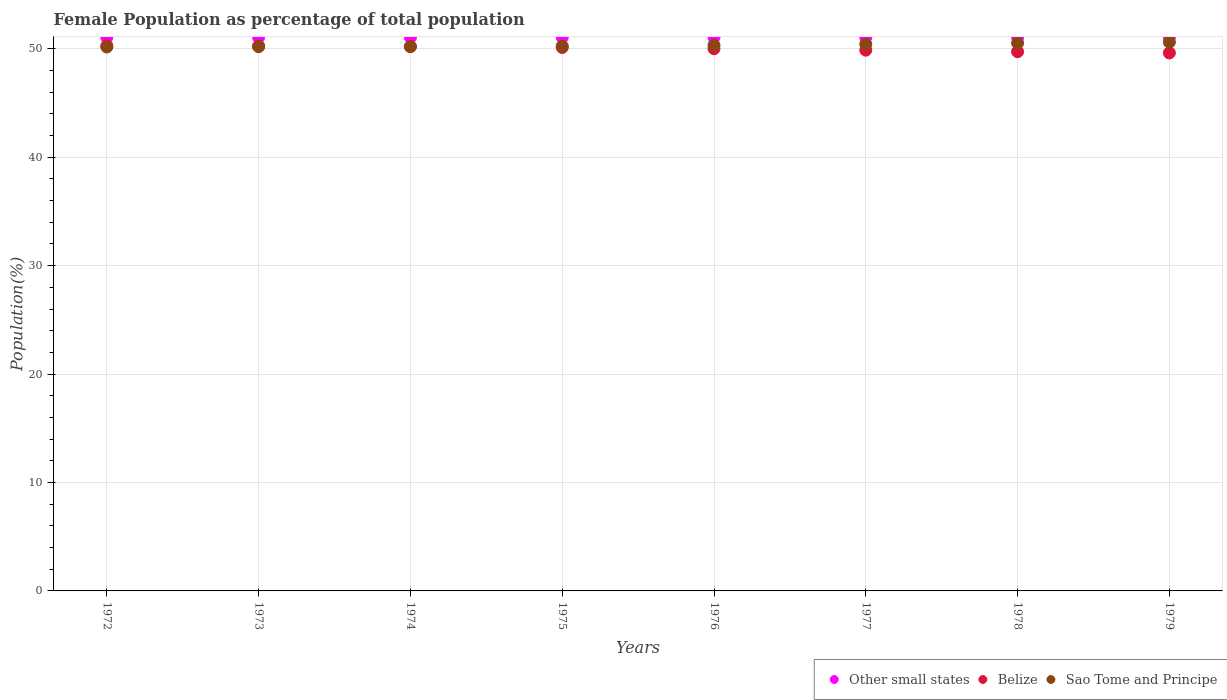How many different coloured dotlines are there?
Ensure brevity in your answer.  3. What is the female population in in Other small states in 1973?
Provide a succinct answer. 51.06. Across all years, what is the maximum female population in in Sao Tome and Principe?
Offer a very short reply. 50.61. Across all years, what is the minimum female population in in Sao Tome and Principe?
Provide a short and direct response. 50.17. In which year was the female population in in Other small states maximum?
Your answer should be very brief. 1976. In which year was the female population in in Belize minimum?
Your response must be concise. 1979. What is the total female population in in Belize in the graph?
Make the answer very short. 400.12. What is the difference between the female population in in Other small states in 1974 and that in 1975?
Keep it short and to the point. -0. What is the difference between the female population in in Belize in 1979 and the female population in in Sao Tome and Principe in 1972?
Make the answer very short. -0.55. What is the average female population in in Belize per year?
Ensure brevity in your answer.  50.02. In the year 1974, what is the difference between the female population in in Sao Tome and Principe and female population in in Belize?
Offer a terse response. 0.01. What is the ratio of the female population in in Sao Tome and Principe in 1975 to that in 1977?
Ensure brevity in your answer.  1. What is the difference between the highest and the second highest female population in in Sao Tome and Principe?
Keep it short and to the point. 0.08. What is the difference between the highest and the lowest female population in in Belize?
Offer a terse response. 0.67. In how many years, is the female population in in Sao Tome and Principe greater than the average female population in in Sao Tome and Principe taken over all years?
Keep it short and to the point. 3. Is the sum of the female population in in Other small states in 1974 and 1979 greater than the maximum female population in in Sao Tome and Principe across all years?
Your response must be concise. Yes. Does the female population in in Sao Tome and Principe monotonically increase over the years?
Provide a succinct answer. Yes. Is the female population in in Sao Tome and Principe strictly greater than the female population in in Belize over the years?
Give a very brief answer. No. How many years are there in the graph?
Your response must be concise. 8. What is the difference between two consecutive major ticks on the Y-axis?
Your response must be concise. 10. Does the graph contain any zero values?
Your answer should be very brief. No. Does the graph contain grids?
Keep it short and to the point. Yes. Where does the legend appear in the graph?
Your answer should be compact. Bottom right. How are the legend labels stacked?
Your answer should be very brief. Horizontal. What is the title of the graph?
Keep it short and to the point. Female Population as percentage of total population. What is the label or title of the X-axis?
Provide a short and direct response. Years. What is the label or title of the Y-axis?
Provide a short and direct response. Population(%). What is the Population(%) of Other small states in 1972?
Offer a terse response. 51.05. What is the Population(%) in Belize in 1972?
Your answer should be very brief. 50.29. What is the Population(%) in Sao Tome and Principe in 1972?
Your answer should be very brief. 50.17. What is the Population(%) in Other small states in 1973?
Keep it short and to the point. 51.06. What is the Population(%) in Belize in 1973?
Ensure brevity in your answer.  50.26. What is the Population(%) of Sao Tome and Principe in 1973?
Make the answer very short. 50.2. What is the Population(%) of Other small states in 1974?
Give a very brief answer. 51.06. What is the Population(%) of Belize in 1974?
Offer a terse response. 50.2. What is the Population(%) of Sao Tome and Principe in 1974?
Make the answer very short. 50.21. What is the Population(%) of Other small states in 1975?
Provide a short and direct response. 51.06. What is the Population(%) of Belize in 1975?
Offer a terse response. 50.12. What is the Population(%) of Sao Tome and Principe in 1975?
Ensure brevity in your answer.  50.26. What is the Population(%) in Other small states in 1976?
Keep it short and to the point. 51.06. What is the Population(%) in Belize in 1976?
Your response must be concise. 50.01. What is the Population(%) of Sao Tome and Principe in 1976?
Give a very brief answer. 50.33. What is the Population(%) of Other small states in 1977?
Provide a short and direct response. 51.06. What is the Population(%) of Belize in 1977?
Offer a very short reply. 49.88. What is the Population(%) of Sao Tome and Principe in 1977?
Make the answer very short. 50.43. What is the Population(%) of Other small states in 1978?
Provide a short and direct response. 51.05. What is the Population(%) of Belize in 1978?
Your answer should be compact. 49.74. What is the Population(%) in Sao Tome and Principe in 1978?
Your response must be concise. 50.53. What is the Population(%) of Other small states in 1979?
Give a very brief answer. 51.04. What is the Population(%) in Belize in 1979?
Your answer should be compact. 49.62. What is the Population(%) in Sao Tome and Principe in 1979?
Your answer should be compact. 50.61. Across all years, what is the maximum Population(%) in Other small states?
Offer a terse response. 51.06. Across all years, what is the maximum Population(%) in Belize?
Your answer should be very brief. 50.29. Across all years, what is the maximum Population(%) of Sao Tome and Principe?
Your answer should be compact. 50.61. Across all years, what is the minimum Population(%) of Other small states?
Offer a very short reply. 51.04. Across all years, what is the minimum Population(%) in Belize?
Keep it short and to the point. 49.62. Across all years, what is the minimum Population(%) of Sao Tome and Principe?
Offer a terse response. 50.17. What is the total Population(%) of Other small states in the graph?
Ensure brevity in your answer.  408.44. What is the total Population(%) in Belize in the graph?
Your response must be concise. 400.12. What is the total Population(%) in Sao Tome and Principe in the graph?
Give a very brief answer. 402.75. What is the difference between the Population(%) in Other small states in 1972 and that in 1973?
Offer a terse response. -0. What is the difference between the Population(%) in Belize in 1972 and that in 1973?
Provide a short and direct response. 0.03. What is the difference between the Population(%) in Sao Tome and Principe in 1972 and that in 1973?
Offer a very short reply. -0.03. What is the difference between the Population(%) in Other small states in 1972 and that in 1974?
Your answer should be compact. -0. What is the difference between the Population(%) in Belize in 1972 and that in 1974?
Offer a terse response. 0.08. What is the difference between the Population(%) in Sao Tome and Principe in 1972 and that in 1974?
Keep it short and to the point. -0.05. What is the difference between the Population(%) in Other small states in 1972 and that in 1975?
Make the answer very short. -0. What is the difference between the Population(%) in Belize in 1972 and that in 1975?
Provide a short and direct response. 0.16. What is the difference between the Population(%) in Sao Tome and Principe in 1972 and that in 1975?
Your answer should be very brief. -0.09. What is the difference between the Population(%) in Other small states in 1972 and that in 1976?
Your answer should be very brief. -0. What is the difference between the Population(%) in Belize in 1972 and that in 1976?
Provide a short and direct response. 0.28. What is the difference between the Population(%) of Sao Tome and Principe in 1972 and that in 1976?
Your response must be concise. -0.16. What is the difference between the Population(%) of Other small states in 1972 and that in 1977?
Your response must be concise. -0. What is the difference between the Population(%) in Belize in 1972 and that in 1977?
Make the answer very short. 0.41. What is the difference between the Population(%) of Sao Tome and Principe in 1972 and that in 1977?
Give a very brief answer. -0.26. What is the difference between the Population(%) of Other small states in 1972 and that in 1978?
Your answer should be compact. 0. What is the difference between the Population(%) of Belize in 1972 and that in 1978?
Offer a very short reply. 0.55. What is the difference between the Population(%) of Sao Tome and Principe in 1972 and that in 1978?
Ensure brevity in your answer.  -0.36. What is the difference between the Population(%) of Other small states in 1972 and that in 1979?
Ensure brevity in your answer.  0.01. What is the difference between the Population(%) in Belize in 1972 and that in 1979?
Your response must be concise. 0.67. What is the difference between the Population(%) in Sao Tome and Principe in 1972 and that in 1979?
Offer a very short reply. -0.44. What is the difference between the Population(%) in Other small states in 1973 and that in 1974?
Offer a terse response. -0. What is the difference between the Population(%) of Belize in 1973 and that in 1974?
Give a very brief answer. 0.05. What is the difference between the Population(%) in Sao Tome and Principe in 1973 and that in 1974?
Give a very brief answer. -0.02. What is the difference between the Population(%) of Other small states in 1973 and that in 1975?
Offer a very short reply. -0. What is the difference between the Population(%) of Belize in 1973 and that in 1975?
Offer a terse response. 0.13. What is the difference between the Population(%) of Sao Tome and Principe in 1973 and that in 1975?
Provide a short and direct response. -0.06. What is the difference between the Population(%) of Other small states in 1973 and that in 1976?
Keep it short and to the point. -0. What is the difference between the Population(%) of Belize in 1973 and that in 1976?
Keep it short and to the point. 0.24. What is the difference between the Population(%) of Sao Tome and Principe in 1973 and that in 1976?
Your response must be concise. -0.14. What is the difference between the Population(%) in Other small states in 1973 and that in 1977?
Offer a very short reply. -0. What is the difference between the Population(%) in Belize in 1973 and that in 1977?
Offer a terse response. 0.38. What is the difference between the Population(%) in Sao Tome and Principe in 1973 and that in 1977?
Your answer should be compact. -0.23. What is the difference between the Population(%) in Other small states in 1973 and that in 1978?
Provide a short and direct response. 0. What is the difference between the Population(%) in Belize in 1973 and that in 1978?
Provide a succinct answer. 0.52. What is the difference between the Population(%) in Sao Tome and Principe in 1973 and that in 1978?
Keep it short and to the point. -0.33. What is the difference between the Population(%) of Other small states in 1973 and that in 1979?
Give a very brief answer. 0.01. What is the difference between the Population(%) of Belize in 1973 and that in 1979?
Provide a short and direct response. 0.64. What is the difference between the Population(%) in Sao Tome and Principe in 1973 and that in 1979?
Your answer should be very brief. -0.42. What is the difference between the Population(%) in Other small states in 1974 and that in 1975?
Keep it short and to the point. -0. What is the difference between the Population(%) in Belize in 1974 and that in 1975?
Offer a very short reply. 0.08. What is the difference between the Population(%) of Sao Tome and Principe in 1974 and that in 1975?
Provide a short and direct response. -0.04. What is the difference between the Population(%) in Other small states in 1974 and that in 1976?
Ensure brevity in your answer.  -0. What is the difference between the Population(%) in Belize in 1974 and that in 1976?
Your answer should be compact. 0.19. What is the difference between the Population(%) in Sao Tome and Principe in 1974 and that in 1976?
Provide a short and direct response. -0.12. What is the difference between the Population(%) of Other small states in 1974 and that in 1977?
Your response must be concise. -0. What is the difference between the Population(%) in Belize in 1974 and that in 1977?
Provide a short and direct response. 0.33. What is the difference between the Population(%) in Sao Tome and Principe in 1974 and that in 1977?
Ensure brevity in your answer.  -0.22. What is the difference between the Population(%) in Other small states in 1974 and that in 1978?
Offer a very short reply. 0. What is the difference between the Population(%) of Belize in 1974 and that in 1978?
Offer a terse response. 0.47. What is the difference between the Population(%) of Sao Tome and Principe in 1974 and that in 1978?
Your answer should be compact. -0.32. What is the difference between the Population(%) of Other small states in 1974 and that in 1979?
Your answer should be very brief. 0.01. What is the difference between the Population(%) of Belize in 1974 and that in 1979?
Offer a terse response. 0.58. What is the difference between the Population(%) of Sao Tome and Principe in 1974 and that in 1979?
Provide a succinct answer. -0.4. What is the difference between the Population(%) in Other small states in 1975 and that in 1976?
Provide a succinct answer. -0. What is the difference between the Population(%) of Belize in 1975 and that in 1976?
Provide a short and direct response. 0.11. What is the difference between the Population(%) of Sao Tome and Principe in 1975 and that in 1976?
Offer a terse response. -0.08. What is the difference between the Population(%) in Other small states in 1975 and that in 1977?
Provide a succinct answer. -0. What is the difference between the Population(%) in Belize in 1975 and that in 1977?
Offer a terse response. 0.25. What is the difference between the Population(%) in Sao Tome and Principe in 1975 and that in 1977?
Ensure brevity in your answer.  -0.18. What is the difference between the Population(%) of Other small states in 1975 and that in 1978?
Offer a very short reply. 0. What is the difference between the Population(%) in Belize in 1975 and that in 1978?
Your answer should be compact. 0.39. What is the difference between the Population(%) in Sao Tome and Principe in 1975 and that in 1978?
Keep it short and to the point. -0.28. What is the difference between the Population(%) in Other small states in 1975 and that in 1979?
Make the answer very short. 0.01. What is the difference between the Population(%) of Belize in 1975 and that in 1979?
Give a very brief answer. 0.5. What is the difference between the Population(%) in Sao Tome and Principe in 1975 and that in 1979?
Provide a short and direct response. -0.36. What is the difference between the Population(%) in Belize in 1976 and that in 1977?
Keep it short and to the point. 0.14. What is the difference between the Population(%) in Sao Tome and Principe in 1976 and that in 1977?
Your answer should be very brief. -0.1. What is the difference between the Population(%) in Other small states in 1976 and that in 1978?
Keep it short and to the point. 0. What is the difference between the Population(%) in Belize in 1976 and that in 1978?
Your response must be concise. 0.28. What is the difference between the Population(%) in Sao Tome and Principe in 1976 and that in 1978?
Provide a succinct answer. -0.2. What is the difference between the Population(%) of Other small states in 1976 and that in 1979?
Provide a short and direct response. 0.01. What is the difference between the Population(%) of Belize in 1976 and that in 1979?
Keep it short and to the point. 0.39. What is the difference between the Population(%) in Sao Tome and Principe in 1976 and that in 1979?
Ensure brevity in your answer.  -0.28. What is the difference between the Population(%) of Other small states in 1977 and that in 1978?
Offer a very short reply. 0. What is the difference between the Population(%) of Belize in 1977 and that in 1978?
Provide a succinct answer. 0.14. What is the difference between the Population(%) of Sao Tome and Principe in 1977 and that in 1978?
Offer a terse response. -0.1. What is the difference between the Population(%) of Other small states in 1977 and that in 1979?
Your answer should be very brief. 0.01. What is the difference between the Population(%) of Belize in 1977 and that in 1979?
Keep it short and to the point. 0.26. What is the difference between the Population(%) in Sao Tome and Principe in 1977 and that in 1979?
Your answer should be compact. -0.18. What is the difference between the Population(%) of Other small states in 1978 and that in 1979?
Offer a terse response. 0.01. What is the difference between the Population(%) of Belize in 1978 and that in 1979?
Provide a succinct answer. 0.12. What is the difference between the Population(%) in Sao Tome and Principe in 1978 and that in 1979?
Your answer should be compact. -0.08. What is the difference between the Population(%) in Other small states in 1972 and the Population(%) in Belize in 1973?
Keep it short and to the point. 0.8. What is the difference between the Population(%) of Other small states in 1972 and the Population(%) of Sao Tome and Principe in 1973?
Offer a terse response. 0.86. What is the difference between the Population(%) in Belize in 1972 and the Population(%) in Sao Tome and Principe in 1973?
Make the answer very short. 0.09. What is the difference between the Population(%) in Other small states in 1972 and the Population(%) in Belize in 1974?
Offer a terse response. 0.85. What is the difference between the Population(%) of Other small states in 1972 and the Population(%) of Sao Tome and Principe in 1974?
Provide a short and direct response. 0.84. What is the difference between the Population(%) in Belize in 1972 and the Population(%) in Sao Tome and Principe in 1974?
Your response must be concise. 0.07. What is the difference between the Population(%) in Other small states in 1972 and the Population(%) in Belize in 1975?
Keep it short and to the point. 0.93. What is the difference between the Population(%) of Other small states in 1972 and the Population(%) of Sao Tome and Principe in 1975?
Give a very brief answer. 0.8. What is the difference between the Population(%) of Belize in 1972 and the Population(%) of Sao Tome and Principe in 1975?
Your response must be concise. 0.03. What is the difference between the Population(%) of Other small states in 1972 and the Population(%) of Belize in 1976?
Give a very brief answer. 1.04. What is the difference between the Population(%) of Other small states in 1972 and the Population(%) of Sao Tome and Principe in 1976?
Your answer should be compact. 0.72. What is the difference between the Population(%) in Belize in 1972 and the Population(%) in Sao Tome and Principe in 1976?
Give a very brief answer. -0.04. What is the difference between the Population(%) of Other small states in 1972 and the Population(%) of Belize in 1977?
Keep it short and to the point. 1.18. What is the difference between the Population(%) in Other small states in 1972 and the Population(%) in Sao Tome and Principe in 1977?
Give a very brief answer. 0.62. What is the difference between the Population(%) of Belize in 1972 and the Population(%) of Sao Tome and Principe in 1977?
Your answer should be very brief. -0.14. What is the difference between the Population(%) in Other small states in 1972 and the Population(%) in Belize in 1978?
Give a very brief answer. 1.32. What is the difference between the Population(%) of Other small states in 1972 and the Population(%) of Sao Tome and Principe in 1978?
Keep it short and to the point. 0.52. What is the difference between the Population(%) in Belize in 1972 and the Population(%) in Sao Tome and Principe in 1978?
Keep it short and to the point. -0.24. What is the difference between the Population(%) in Other small states in 1972 and the Population(%) in Belize in 1979?
Offer a very short reply. 1.43. What is the difference between the Population(%) of Other small states in 1972 and the Population(%) of Sao Tome and Principe in 1979?
Offer a terse response. 0.44. What is the difference between the Population(%) of Belize in 1972 and the Population(%) of Sao Tome and Principe in 1979?
Give a very brief answer. -0.32. What is the difference between the Population(%) in Other small states in 1973 and the Population(%) in Belize in 1974?
Your response must be concise. 0.85. What is the difference between the Population(%) of Other small states in 1973 and the Population(%) of Sao Tome and Principe in 1974?
Ensure brevity in your answer.  0.84. What is the difference between the Population(%) in Belize in 1973 and the Population(%) in Sao Tome and Principe in 1974?
Keep it short and to the point. 0.04. What is the difference between the Population(%) of Other small states in 1973 and the Population(%) of Belize in 1975?
Your answer should be very brief. 0.93. What is the difference between the Population(%) in Other small states in 1973 and the Population(%) in Sao Tome and Principe in 1975?
Ensure brevity in your answer.  0.8. What is the difference between the Population(%) in Belize in 1973 and the Population(%) in Sao Tome and Principe in 1975?
Keep it short and to the point. 0. What is the difference between the Population(%) of Other small states in 1973 and the Population(%) of Belize in 1976?
Your answer should be very brief. 1.04. What is the difference between the Population(%) of Other small states in 1973 and the Population(%) of Sao Tome and Principe in 1976?
Your answer should be very brief. 0.72. What is the difference between the Population(%) in Belize in 1973 and the Population(%) in Sao Tome and Principe in 1976?
Keep it short and to the point. -0.08. What is the difference between the Population(%) in Other small states in 1973 and the Population(%) in Belize in 1977?
Give a very brief answer. 1.18. What is the difference between the Population(%) in Other small states in 1973 and the Population(%) in Sao Tome and Principe in 1977?
Provide a short and direct response. 0.62. What is the difference between the Population(%) in Belize in 1973 and the Population(%) in Sao Tome and Principe in 1977?
Give a very brief answer. -0.17. What is the difference between the Population(%) of Other small states in 1973 and the Population(%) of Belize in 1978?
Provide a short and direct response. 1.32. What is the difference between the Population(%) of Other small states in 1973 and the Population(%) of Sao Tome and Principe in 1978?
Provide a short and direct response. 0.52. What is the difference between the Population(%) of Belize in 1973 and the Population(%) of Sao Tome and Principe in 1978?
Keep it short and to the point. -0.28. What is the difference between the Population(%) in Other small states in 1973 and the Population(%) in Belize in 1979?
Make the answer very short. 1.43. What is the difference between the Population(%) of Other small states in 1973 and the Population(%) of Sao Tome and Principe in 1979?
Give a very brief answer. 0.44. What is the difference between the Population(%) of Belize in 1973 and the Population(%) of Sao Tome and Principe in 1979?
Make the answer very short. -0.36. What is the difference between the Population(%) in Other small states in 1974 and the Population(%) in Belize in 1975?
Offer a very short reply. 0.93. What is the difference between the Population(%) in Other small states in 1974 and the Population(%) in Sao Tome and Principe in 1975?
Offer a terse response. 0.8. What is the difference between the Population(%) in Belize in 1974 and the Population(%) in Sao Tome and Principe in 1975?
Offer a very short reply. -0.05. What is the difference between the Population(%) in Other small states in 1974 and the Population(%) in Belize in 1976?
Make the answer very short. 1.04. What is the difference between the Population(%) of Other small states in 1974 and the Population(%) of Sao Tome and Principe in 1976?
Offer a very short reply. 0.72. What is the difference between the Population(%) in Belize in 1974 and the Population(%) in Sao Tome and Principe in 1976?
Your answer should be very brief. -0.13. What is the difference between the Population(%) in Other small states in 1974 and the Population(%) in Belize in 1977?
Keep it short and to the point. 1.18. What is the difference between the Population(%) of Other small states in 1974 and the Population(%) of Sao Tome and Principe in 1977?
Your answer should be compact. 0.63. What is the difference between the Population(%) in Belize in 1974 and the Population(%) in Sao Tome and Principe in 1977?
Give a very brief answer. -0.23. What is the difference between the Population(%) in Other small states in 1974 and the Population(%) in Belize in 1978?
Provide a succinct answer. 1.32. What is the difference between the Population(%) of Other small states in 1974 and the Population(%) of Sao Tome and Principe in 1978?
Give a very brief answer. 0.52. What is the difference between the Population(%) in Belize in 1974 and the Population(%) in Sao Tome and Principe in 1978?
Provide a succinct answer. -0.33. What is the difference between the Population(%) of Other small states in 1974 and the Population(%) of Belize in 1979?
Keep it short and to the point. 1.44. What is the difference between the Population(%) of Other small states in 1974 and the Population(%) of Sao Tome and Principe in 1979?
Offer a terse response. 0.44. What is the difference between the Population(%) in Belize in 1974 and the Population(%) in Sao Tome and Principe in 1979?
Offer a terse response. -0.41. What is the difference between the Population(%) in Other small states in 1975 and the Population(%) in Belize in 1976?
Give a very brief answer. 1.05. What is the difference between the Population(%) in Other small states in 1975 and the Population(%) in Sao Tome and Principe in 1976?
Your answer should be compact. 0.73. What is the difference between the Population(%) in Belize in 1975 and the Population(%) in Sao Tome and Principe in 1976?
Ensure brevity in your answer.  -0.21. What is the difference between the Population(%) of Other small states in 1975 and the Population(%) of Belize in 1977?
Offer a very short reply. 1.18. What is the difference between the Population(%) of Other small states in 1975 and the Population(%) of Sao Tome and Principe in 1977?
Your answer should be compact. 0.63. What is the difference between the Population(%) of Belize in 1975 and the Population(%) of Sao Tome and Principe in 1977?
Your answer should be very brief. -0.31. What is the difference between the Population(%) in Other small states in 1975 and the Population(%) in Belize in 1978?
Provide a short and direct response. 1.32. What is the difference between the Population(%) of Other small states in 1975 and the Population(%) of Sao Tome and Principe in 1978?
Offer a terse response. 0.53. What is the difference between the Population(%) of Belize in 1975 and the Population(%) of Sao Tome and Principe in 1978?
Ensure brevity in your answer.  -0.41. What is the difference between the Population(%) in Other small states in 1975 and the Population(%) in Belize in 1979?
Provide a short and direct response. 1.44. What is the difference between the Population(%) of Other small states in 1975 and the Population(%) of Sao Tome and Principe in 1979?
Make the answer very short. 0.45. What is the difference between the Population(%) of Belize in 1975 and the Population(%) of Sao Tome and Principe in 1979?
Give a very brief answer. -0.49. What is the difference between the Population(%) in Other small states in 1976 and the Population(%) in Belize in 1977?
Provide a succinct answer. 1.18. What is the difference between the Population(%) in Other small states in 1976 and the Population(%) in Sao Tome and Principe in 1977?
Provide a succinct answer. 0.63. What is the difference between the Population(%) in Belize in 1976 and the Population(%) in Sao Tome and Principe in 1977?
Your response must be concise. -0.42. What is the difference between the Population(%) in Other small states in 1976 and the Population(%) in Belize in 1978?
Provide a succinct answer. 1.32. What is the difference between the Population(%) of Other small states in 1976 and the Population(%) of Sao Tome and Principe in 1978?
Make the answer very short. 0.53. What is the difference between the Population(%) in Belize in 1976 and the Population(%) in Sao Tome and Principe in 1978?
Ensure brevity in your answer.  -0.52. What is the difference between the Population(%) of Other small states in 1976 and the Population(%) of Belize in 1979?
Your response must be concise. 1.44. What is the difference between the Population(%) of Other small states in 1976 and the Population(%) of Sao Tome and Principe in 1979?
Your answer should be compact. 0.45. What is the difference between the Population(%) of Belize in 1976 and the Population(%) of Sao Tome and Principe in 1979?
Provide a succinct answer. -0.6. What is the difference between the Population(%) of Other small states in 1977 and the Population(%) of Belize in 1978?
Keep it short and to the point. 1.32. What is the difference between the Population(%) in Other small states in 1977 and the Population(%) in Sao Tome and Principe in 1978?
Provide a succinct answer. 0.53. What is the difference between the Population(%) in Belize in 1977 and the Population(%) in Sao Tome and Principe in 1978?
Your response must be concise. -0.66. What is the difference between the Population(%) in Other small states in 1977 and the Population(%) in Belize in 1979?
Offer a very short reply. 1.44. What is the difference between the Population(%) of Other small states in 1977 and the Population(%) of Sao Tome and Principe in 1979?
Keep it short and to the point. 0.45. What is the difference between the Population(%) in Belize in 1977 and the Population(%) in Sao Tome and Principe in 1979?
Ensure brevity in your answer.  -0.74. What is the difference between the Population(%) in Other small states in 1978 and the Population(%) in Belize in 1979?
Provide a succinct answer. 1.43. What is the difference between the Population(%) of Other small states in 1978 and the Population(%) of Sao Tome and Principe in 1979?
Your response must be concise. 0.44. What is the difference between the Population(%) in Belize in 1978 and the Population(%) in Sao Tome and Principe in 1979?
Keep it short and to the point. -0.88. What is the average Population(%) of Other small states per year?
Ensure brevity in your answer.  51.06. What is the average Population(%) in Belize per year?
Make the answer very short. 50.02. What is the average Population(%) of Sao Tome and Principe per year?
Ensure brevity in your answer.  50.34. In the year 1972, what is the difference between the Population(%) of Other small states and Population(%) of Belize?
Your response must be concise. 0.77. In the year 1972, what is the difference between the Population(%) in Other small states and Population(%) in Sao Tome and Principe?
Provide a succinct answer. 0.89. In the year 1972, what is the difference between the Population(%) of Belize and Population(%) of Sao Tome and Principe?
Offer a very short reply. 0.12. In the year 1973, what is the difference between the Population(%) of Other small states and Population(%) of Belize?
Keep it short and to the point. 0.8. In the year 1973, what is the difference between the Population(%) of Other small states and Population(%) of Sao Tome and Principe?
Give a very brief answer. 0.86. In the year 1973, what is the difference between the Population(%) of Belize and Population(%) of Sao Tome and Principe?
Your answer should be very brief. 0.06. In the year 1974, what is the difference between the Population(%) of Other small states and Population(%) of Belize?
Give a very brief answer. 0.85. In the year 1974, what is the difference between the Population(%) in Other small states and Population(%) in Sao Tome and Principe?
Ensure brevity in your answer.  0.84. In the year 1974, what is the difference between the Population(%) of Belize and Population(%) of Sao Tome and Principe?
Keep it short and to the point. -0.01. In the year 1975, what is the difference between the Population(%) in Other small states and Population(%) in Belize?
Give a very brief answer. 0.93. In the year 1975, what is the difference between the Population(%) of Other small states and Population(%) of Sao Tome and Principe?
Provide a succinct answer. 0.8. In the year 1975, what is the difference between the Population(%) in Belize and Population(%) in Sao Tome and Principe?
Your response must be concise. -0.13. In the year 1976, what is the difference between the Population(%) of Other small states and Population(%) of Belize?
Your answer should be very brief. 1.05. In the year 1976, what is the difference between the Population(%) of Other small states and Population(%) of Sao Tome and Principe?
Ensure brevity in your answer.  0.73. In the year 1976, what is the difference between the Population(%) of Belize and Population(%) of Sao Tome and Principe?
Give a very brief answer. -0.32. In the year 1977, what is the difference between the Population(%) of Other small states and Population(%) of Belize?
Your answer should be very brief. 1.18. In the year 1977, what is the difference between the Population(%) in Other small states and Population(%) in Sao Tome and Principe?
Your answer should be very brief. 0.63. In the year 1977, what is the difference between the Population(%) in Belize and Population(%) in Sao Tome and Principe?
Make the answer very short. -0.55. In the year 1978, what is the difference between the Population(%) of Other small states and Population(%) of Belize?
Give a very brief answer. 1.32. In the year 1978, what is the difference between the Population(%) in Other small states and Population(%) in Sao Tome and Principe?
Ensure brevity in your answer.  0.52. In the year 1978, what is the difference between the Population(%) of Belize and Population(%) of Sao Tome and Principe?
Keep it short and to the point. -0.79. In the year 1979, what is the difference between the Population(%) of Other small states and Population(%) of Belize?
Provide a short and direct response. 1.42. In the year 1979, what is the difference between the Population(%) of Other small states and Population(%) of Sao Tome and Principe?
Your answer should be very brief. 0.43. In the year 1979, what is the difference between the Population(%) in Belize and Population(%) in Sao Tome and Principe?
Ensure brevity in your answer.  -0.99. What is the ratio of the Population(%) of Other small states in 1972 to that in 1974?
Provide a short and direct response. 1. What is the ratio of the Population(%) of Belize in 1972 to that in 1974?
Offer a terse response. 1. What is the ratio of the Population(%) of Other small states in 1972 to that in 1975?
Ensure brevity in your answer.  1. What is the ratio of the Population(%) in Sao Tome and Principe in 1972 to that in 1975?
Provide a short and direct response. 1. What is the ratio of the Population(%) in Other small states in 1972 to that in 1976?
Give a very brief answer. 1. What is the ratio of the Population(%) in Belize in 1972 to that in 1976?
Keep it short and to the point. 1.01. What is the ratio of the Population(%) of Sao Tome and Principe in 1972 to that in 1976?
Provide a short and direct response. 1. What is the ratio of the Population(%) in Belize in 1972 to that in 1977?
Keep it short and to the point. 1.01. What is the ratio of the Population(%) of Belize in 1972 to that in 1978?
Make the answer very short. 1.01. What is the ratio of the Population(%) in Sao Tome and Principe in 1972 to that in 1978?
Your answer should be very brief. 0.99. What is the ratio of the Population(%) of Belize in 1972 to that in 1979?
Provide a succinct answer. 1.01. What is the ratio of the Population(%) in Belize in 1973 to that in 1974?
Make the answer very short. 1. What is the ratio of the Population(%) of Sao Tome and Principe in 1973 to that in 1974?
Your answer should be very brief. 1. What is the ratio of the Population(%) of Other small states in 1973 to that in 1975?
Make the answer very short. 1. What is the ratio of the Population(%) in Belize in 1973 to that in 1975?
Offer a terse response. 1. What is the ratio of the Population(%) in Sao Tome and Principe in 1973 to that in 1975?
Keep it short and to the point. 1. What is the ratio of the Population(%) of Sao Tome and Principe in 1973 to that in 1976?
Your answer should be compact. 1. What is the ratio of the Population(%) of Belize in 1973 to that in 1977?
Provide a succinct answer. 1.01. What is the ratio of the Population(%) in Sao Tome and Principe in 1973 to that in 1977?
Offer a very short reply. 1. What is the ratio of the Population(%) in Other small states in 1973 to that in 1978?
Offer a terse response. 1. What is the ratio of the Population(%) in Belize in 1973 to that in 1978?
Your answer should be compact. 1.01. What is the ratio of the Population(%) in Sao Tome and Principe in 1973 to that in 1978?
Offer a terse response. 0.99. What is the ratio of the Population(%) of Other small states in 1973 to that in 1979?
Keep it short and to the point. 1. What is the ratio of the Population(%) of Belize in 1973 to that in 1979?
Your answer should be very brief. 1.01. What is the ratio of the Population(%) of Sao Tome and Principe in 1974 to that in 1975?
Provide a succinct answer. 1. What is the ratio of the Population(%) in Other small states in 1974 to that in 1976?
Your answer should be very brief. 1. What is the ratio of the Population(%) of Other small states in 1974 to that in 1977?
Keep it short and to the point. 1. What is the ratio of the Population(%) of Belize in 1974 to that in 1977?
Your response must be concise. 1.01. What is the ratio of the Population(%) in Belize in 1974 to that in 1978?
Give a very brief answer. 1.01. What is the ratio of the Population(%) in Other small states in 1974 to that in 1979?
Give a very brief answer. 1. What is the ratio of the Population(%) of Belize in 1974 to that in 1979?
Provide a short and direct response. 1.01. What is the ratio of the Population(%) in Other small states in 1975 to that in 1976?
Provide a short and direct response. 1. What is the ratio of the Population(%) in Belize in 1975 to that in 1976?
Offer a very short reply. 1. What is the ratio of the Population(%) in Sao Tome and Principe in 1975 to that in 1976?
Offer a very short reply. 1. What is the ratio of the Population(%) in Other small states in 1975 to that in 1977?
Give a very brief answer. 1. What is the ratio of the Population(%) of Belize in 1975 to that in 1977?
Your answer should be compact. 1. What is the ratio of the Population(%) of Other small states in 1975 to that in 1979?
Provide a succinct answer. 1. What is the ratio of the Population(%) in Sao Tome and Principe in 1975 to that in 1979?
Your answer should be compact. 0.99. What is the ratio of the Population(%) of Belize in 1976 to that in 1977?
Your answer should be compact. 1. What is the ratio of the Population(%) in Other small states in 1976 to that in 1978?
Make the answer very short. 1. What is the ratio of the Population(%) in Belize in 1976 to that in 1978?
Keep it short and to the point. 1.01. What is the ratio of the Population(%) in Sao Tome and Principe in 1976 to that in 1978?
Offer a very short reply. 1. What is the ratio of the Population(%) in Other small states in 1976 to that in 1979?
Ensure brevity in your answer.  1. What is the ratio of the Population(%) in Belize in 1976 to that in 1979?
Your answer should be compact. 1.01. What is the ratio of the Population(%) in Sao Tome and Principe in 1976 to that in 1979?
Ensure brevity in your answer.  0.99. What is the ratio of the Population(%) of Belize in 1977 to that in 1978?
Your answer should be very brief. 1. What is the ratio of the Population(%) in Sao Tome and Principe in 1977 to that in 1978?
Give a very brief answer. 1. What is the ratio of the Population(%) in Other small states in 1977 to that in 1979?
Keep it short and to the point. 1. What is the ratio of the Population(%) of Belize in 1977 to that in 1979?
Give a very brief answer. 1.01. What is the ratio of the Population(%) in Sao Tome and Principe in 1977 to that in 1979?
Your answer should be compact. 1. What is the ratio of the Population(%) in Other small states in 1978 to that in 1979?
Provide a short and direct response. 1. What is the ratio of the Population(%) of Belize in 1978 to that in 1979?
Offer a very short reply. 1. What is the ratio of the Population(%) in Sao Tome and Principe in 1978 to that in 1979?
Offer a terse response. 1. What is the difference between the highest and the second highest Population(%) in Belize?
Offer a terse response. 0.03. What is the difference between the highest and the second highest Population(%) of Sao Tome and Principe?
Provide a succinct answer. 0.08. What is the difference between the highest and the lowest Population(%) of Other small states?
Your answer should be very brief. 0.01. What is the difference between the highest and the lowest Population(%) in Belize?
Give a very brief answer. 0.67. What is the difference between the highest and the lowest Population(%) in Sao Tome and Principe?
Give a very brief answer. 0.44. 